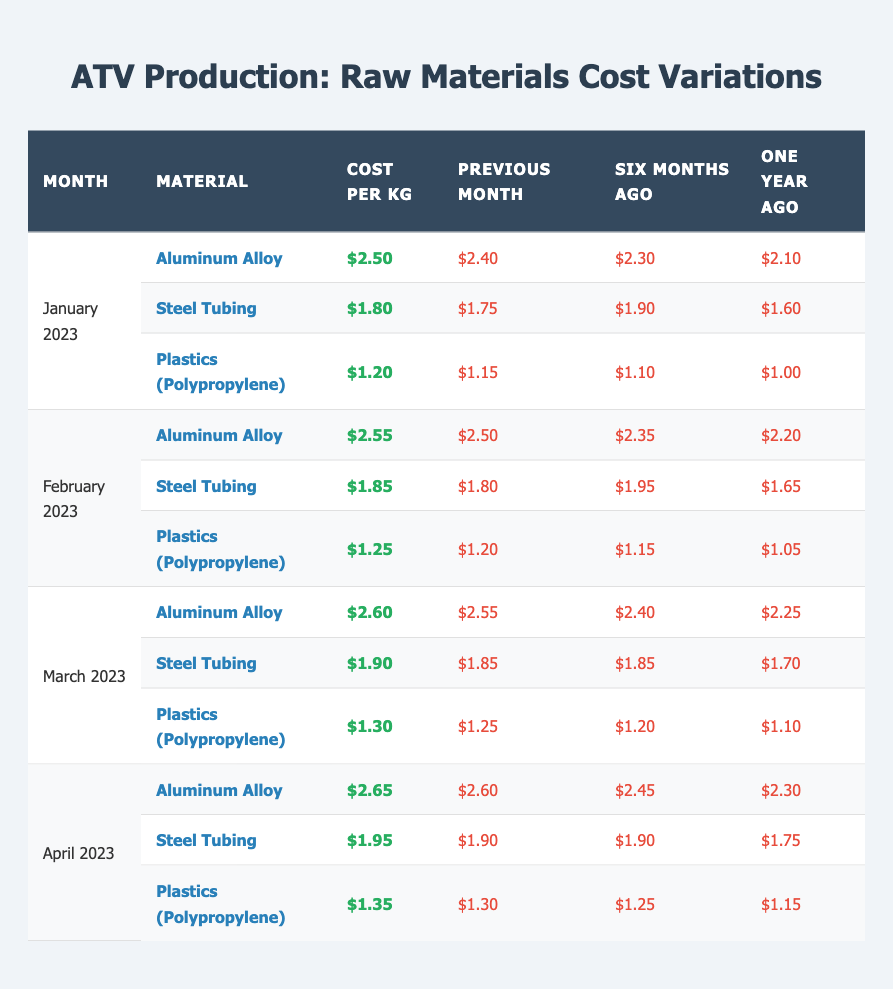What was the cost of Aluminum Alloy in January 2023? The table shows that the cost per kg for Aluminum Alloy in January 2023 is $2.50.
Answer: $2.50 How much did the cost of Steel Tubing increase from January to February 2023? The cost of Steel Tubing in January 2023 was $1.80 and in February 2023 it increased to $1.85. The increase is $1.85 - $1.80 = $0.05.
Answer: $0.05 Was the cost of Plastics (Polypropylene) higher in April 2023 than one year ago? The cost of Plastics (Polypropylene) in April 2023 was $1.35, and one year ago it was $1.15, so $1.35 is greater than $1.15. Therefore, the statement is true.
Answer: Yes What is the average cost per kg of Aluminum Alloy over the first four months of 2023? The costs are $2.50, $2.55, $2.60, and $2.65. Adding these gives $2.50 + $2.55 + $2.60 + $2.65 = $10.30, and dividing by 4 gives an average of $10.30 / 4 = $2.575.
Answer: $2.575 Which material experienced the most significant increase in cost between January and March 2023? Analyzing the costs: Aluminum Alloy went from $2.50 to $2.60 (increase of $0.10), Steel Tubing went from $1.80 to $1.90 (increase of $0.10), and Plastics (Polypropylene) went from $1.20 to $1.30 (increase of $0.10). All three materials had the same increase of $0.10.
Answer: Aluminum Alloy, Steel Tubing, and Plastics (Polypropylene) all increased by $0.10 How much did the cost of Aluminum Alloy increase from one year ago to April 2023? The cost in April 2023 is $2.65, and one year ago it was $2.30. The increase is $2.65 - $2.30 = $0.35.
Answer: $0.35 In which month did the cost of Steel Tubing first exceed $1.90? The cost of Steel Tubing was $1.80 in January, $1.85 in February, $1.90 in March, but then rose to $1.95 in April. The first month exceeding $1.90 is April.
Answer: April 2023 What was the percentage increase in the cost of Plastics (Polypropylene) from six months ago to January 2023? Six months ago, the cost was $1.10, and in January 2023 it was $1.20. The increase is $1.20 - $1.10 = $0.10. The percentage increase is ($0.10 / $1.10) * 100 = 9.09%.
Answer: 9.09% Did the cost of Aluminum Alloy show consistent growth from one year ago to April 2023? Observing the costs: $2.10 one year ago, $2.30 six months ago, $2.40 the previous month, leading to $2.50 in January and increasing to $2.65 in April. Since all values are increasing, the answer is true.
Answer: Yes What is the total cost for one kg of all three materials in February 2023? The costs are $2.55 for Aluminum Alloy, $1.85 for Steel Tubing, and $1.25 for Plastics. Adding these gives $2.55 + $1.85 + $1.25 = $5.65.
Answer: $5.65 